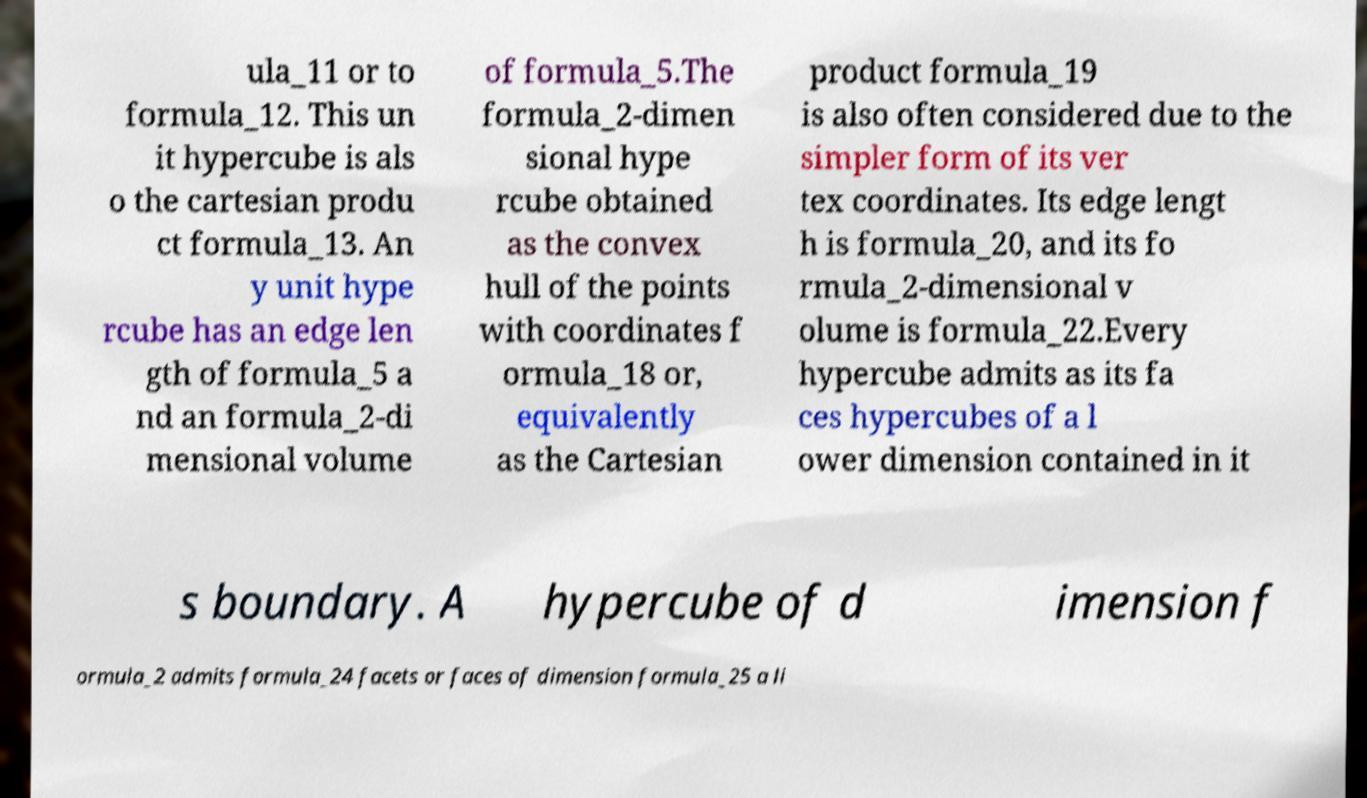Could you extract and type out the text from this image? ula_11 or to formula_12. This un it hypercube is als o the cartesian produ ct formula_13. An y unit hype rcube has an edge len gth of formula_5 a nd an formula_2-di mensional volume of formula_5.The formula_2-dimen sional hype rcube obtained as the convex hull of the points with coordinates f ormula_18 or, equivalently as the Cartesian product formula_19 is also often considered due to the simpler form of its ver tex coordinates. Its edge lengt h is formula_20, and its fo rmula_2-dimensional v olume is formula_22.Every hypercube admits as its fa ces hypercubes of a l ower dimension contained in it s boundary. A hypercube of d imension f ormula_2 admits formula_24 facets or faces of dimension formula_25 a li 